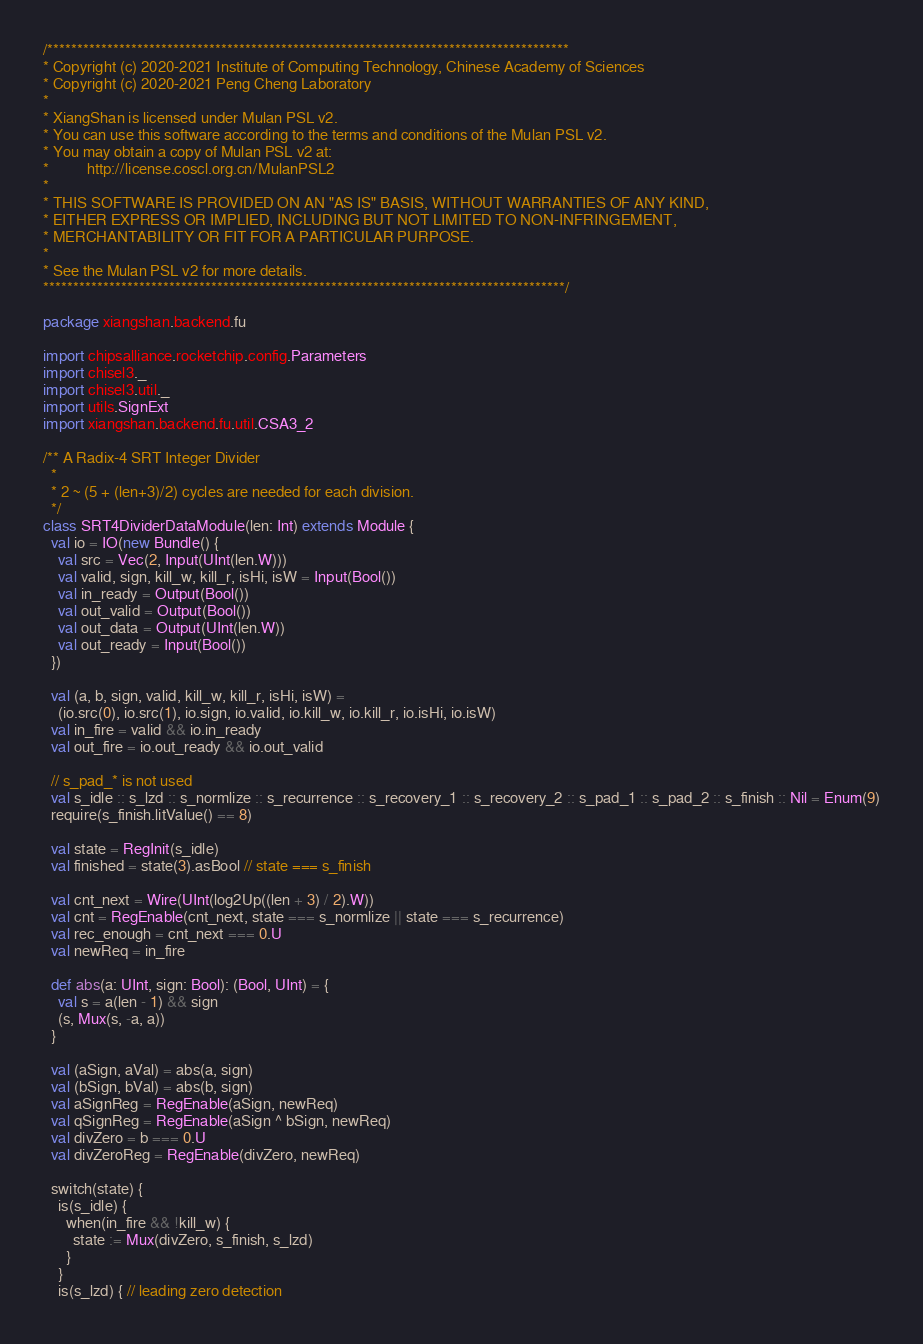<code> <loc_0><loc_0><loc_500><loc_500><_Scala_>/***************************************************************************************
* Copyright (c) 2020-2021 Institute of Computing Technology, Chinese Academy of Sciences
* Copyright (c) 2020-2021 Peng Cheng Laboratory
*
* XiangShan is licensed under Mulan PSL v2.
* You can use this software according to the terms and conditions of the Mulan PSL v2.
* You may obtain a copy of Mulan PSL v2 at:
*          http://license.coscl.org.cn/MulanPSL2
*
* THIS SOFTWARE IS PROVIDED ON AN "AS IS" BASIS, WITHOUT WARRANTIES OF ANY KIND,
* EITHER EXPRESS OR IMPLIED, INCLUDING BUT NOT LIMITED TO NON-INFRINGEMENT,
* MERCHANTABILITY OR FIT FOR A PARTICULAR PURPOSE.
*
* See the Mulan PSL v2 for more details.
***************************************************************************************/

package xiangshan.backend.fu

import chipsalliance.rocketchip.config.Parameters
import chisel3._
import chisel3.util._
import utils.SignExt
import xiangshan.backend.fu.util.CSA3_2

/** A Radix-4 SRT Integer Divider
  *
  * 2 ~ (5 + (len+3)/2) cycles are needed for each division.
  */
class SRT4DividerDataModule(len: Int) extends Module {
  val io = IO(new Bundle() {
    val src = Vec(2, Input(UInt(len.W)))
    val valid, sign, kill_w, kill_r, isHi, isW = Input(Bool())
    val in_ready = Output(Bool())
    val out_valid = Output(Bool())
    val out_data = Output(UInt(len.W))
    val out_ready = Input(Bool())
  })

  val (a, b, sign, valid, kill_w, kill_r, isHi, isW) =
    (io.src(0), io.src(1), io.sign, io.valid, io.kill_w, io.kill_r, io.isHi, io.isW)
  val in_fire = valid && io.in_ready
  val out_fire = io.out_ready && io.out_valid

  // s_pad_* is not used
  val s_idle :: s_lzd :: s_normlize :: s_recurrence :: s_recovery_1 :: s_recovery_2 :: s_pad_1 :: s_pad_2 :: s_finish :: Nil = Enum(9)
  require(s_finish.litValue() == 8)

  val state = RegInit(s_idle)
  val finished = state(3).asBool // state === s_finish

  val cnt_next = Wire(UInt(log2Up((len + 3) / 2).W))
  val cnt = RegEnable(cnt_next, state === s_normlize || state === s_recurrence)
  val rec_enough = cnt_next === 0.U
  val newReq = in_fire

  def abs(a: UInt, sign: Bool): (Bool, UInt) = {
    val s = a(len - 1) && sign
    (s, Mux(s, -a, a))
  }

  val (aSign, aVal) = abs(a, sign)
  val (bSign, bVal) = abs(b, sign)
  val aSignReg = RegEnable(aSign, newReq)
  val qSignReg = RegEnable(aSign ^ bSign, newReq)
  val divZero = b === 0.U
  val divZeroReg = RegEnable(divZero, newReq)

  switch(state) {
    is(s_idle) {
      when(in_fire && !kill_w) {
        state := Mux(divZero, s_finish, s_lzd)
      }
    }
    is(s_lzd) { // leading zero detection</code> 